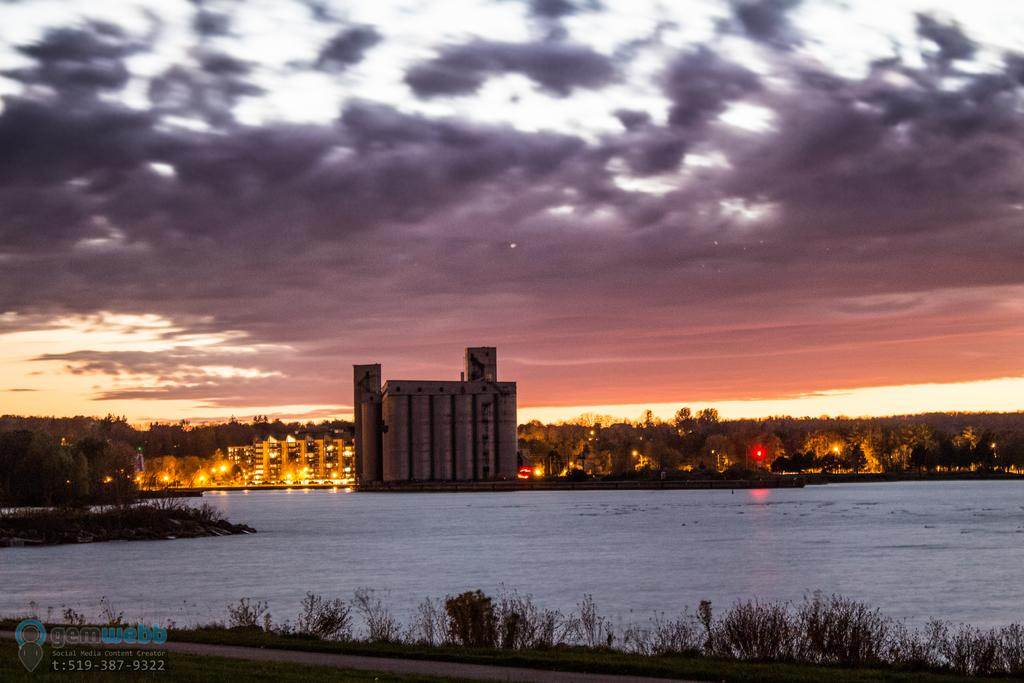What is located in the center of the image? There are buildings, trees, and lights in the center of the image. What can be seen at the bottom of the image? There is water, plants, and ground at the bottom of the image. What is visible in the sky at the top of the image? There are clouds at the top of the image in the sky. What type of base can be seen supporting the buildings in the image? There is no base visible in the image; the buildings are standing on the ground. What kind of offer is being made by the trees in the image? The trees are not making any offers; they are simply part of the landscape in the image. 